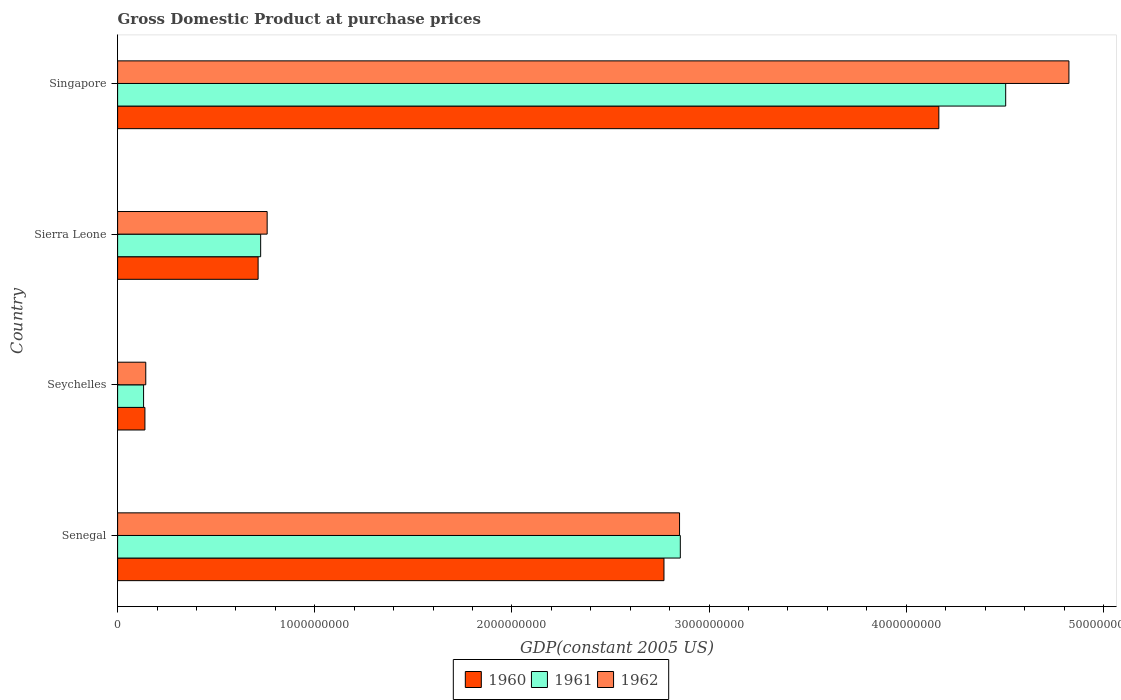How many different coloured bars are there?
Your answer should be very brief. 3. What is the label of the 4th group of bars from the top?
Ensure brevity in your answer.  Senegal. What is the GDP at purchase prices in 1961 in Sierra Leone?
Your answer should be very brief. 7.25e+08. Across all countries, what is the maximum GDP at purchase prices in 1962?
Your answer should be very brief. 4.82e+09. Across all countries, what is the minimum GDP at purchase prices in 1962?
Your answer should be very brief. 1.43e+08. In which country was the GDP at purchase prices in 1962 maximum?
Your answer should be compact. Singapore. In which country was the GDP at purchase prices in 1960 minimum?
Provide a short and direct response. Seychelles. What is the total GDP at purchase prices in 1962 in the graph?
Give a very brief answer. 8.58e+09. What is the difference between the GDP at purchase prices in 1960 in Sierra Leone and that in Singapore?
Your answer should be very brief. -3.45e+09. What is the difference between the GDP at purchase prices in 1961 in Sierra Leone and the GDP at purchase prices in 1962 in Senegal?
Ensure brevity in your answer.  -2.12e+09. What is the average GDP at purchase prices in 1961 per country?
Provide a succinct answer. 2.05e+09. What is the difference between the GDP at purchase prices in 1962 and GDP at purchase prices in 1961 in Seychelles?
Give a very brief answer. 1.11e+07. What is the ratio of the GDP at purchase prices in 1962 in Senegal to that in Seychelles?
Provide a succinct answer. 19.96. Is the GDP at purchase prices in 1960 in Senegal less than that in Singapore?
Your response must be concise. Yes. Is the difference between the GDP at purchase prices in 1962 in Senegal and Singapore greater than the difference between the GDP at purchase prices in 1961 in Senegal and Singapore?
Your answer should be very brief. No. What is the difference between the highest and the second highest GDP at purchase prices in 1962?
Make the answer very short. 1.97e+09. What is the difference between the highest and the lowest GDP at purchase prices in 1961?
Your answer should be very brief. 4.37e+09. In how many countries, is the GDP at purchase prices in 1961 greater than the average GDP at purchase prices in 1961 taken over all countries?
Ensure brevity in your answer.  2. What does the 3rd bar from the top in Seychelles represents?
Your answer should be compact. 1960. What does the 3rd bar from the bottom in Seychelles represents?
Your answer should be compact. 1962. Are all the bars in the graph horizontal?
Offer a terse response. Yes. How many countries are there in the graph?
Give a very brief answer. 4. What is the difference between two consecutive major ticks on the X-axis?
Your response must be concise. 1.00e+09. Does the graph contain any zero values?
Give a very brief answer. No. Does the graph contain grids?
Make the answer very short. No. Where does the legend appear in the graph?
Offer a very short reply. Bottom center. How many legend labels are there?
Ensure brevity in your answer.  3. How are the legend labels stacked?
Give a very brief answer. Horizontal. What is the title of the graph?
Ensure brevity in your answer.  Gross Domestic Product at purchase prices. Does "1991" appear as one of the legend labels in the graph?
Your answer should be very brief. No. What is the label or title of the X-axis?
Make the answer very short. GDP(constant 2005 US). What is the label or title of the Y-axis?
Keep it short and to the point. Country. What is the GDP(constant 2005 US) of 1960 in Senegal?
Make the answer very short. 2.77e+09. What is the GDP(constant 2005 US) in 1961 in Senegal?
Ensure brevity in your answer.  2.85e+09. What is the GDP(constant 2005 US) of 1962 in Senegal?
Your response must be concise. 2.85e+09. What is the GDP(constant 2005 US) of 1960 in Seychelles?
Your answer should be compact. 1.39e+08. What is the GDP(constant 2005 US) in 1961 in Seychelles?
Make the answer very short. 1.32e+08. What is the GDP(constant 2005 US) of 1962 in Seychelles?
Your answer should be compact. 1.43e+08. What is the GDP(constant 2005 US) of 1960 in Sierra Leone?
Ensure brevity in your answer.  7.13e+08. What is the GDP(constant 2005 US) in 1961 in Sierra Leone?
Make the answer very short. 7.25e+08. What is the GDP(constant 2005 US) in 1962 in Sierra Leone?
Give a very brief answer. 7.58e+08. What is the GDP(constant 2005 US) of 1960 in Singapore?
Your answer should be compact. 4.17e+09. What is the GDP(constant 2005 US) of 1961 in Singapore?
Keep it short and to the point. 4.50e+09. What is the GDP(constant 2005 US) in 1962 in Singapore?
Offer a terse response. 4.82e+09. Across all countries, what is the maximum GDP(constant 2005 US) in 1960?
Give a very brief answer. 4.17e+09. Across all countries, what is the maximum GDP(constant 2005 US) in 1961?
Provide a short and direct response. 4.50e+09. Across all countries, what is the maximum GDP(constant 2005 US) in 1962?
Provide a short and direct response. 4.82e+09. Across all countries, what is the minimum GDP(constant 2005 US) in 1960?
Ensure brevity in your answer.  1.39e+08. Across all countries, what is the minimum GDP(constant 2005 US) in 1961?
Your answer should be very brief. 1.32e+08. Across all countries, what is the minimum GDP(constant 2005 US) of 1962?
Give a very brief answer. 1.43e+08. What is the total GDP(constant 2005 US) of 1960 in the graph?
Keep it short and to the point. 7.79e+09. What is the total GDP(constant 2005 US) in 1961 in the graph?
Ensure brevity in your answer.  8.22e+09. What is the total GDP(constant 2005 US) of 1962 in the graph?
Your response must be concise. 8.58e+09. What is the difference between the GDP(constant 2005 US) of 1960 in Senegal and that in Seychelles?
Keep it short and to the point. 2.63e+09. What is the difference between the GDP(constant 2005 US) of 1961 in Senegal and that in Seychelles?
Give a very brief answer. 2.72e+09. What is the difference between the GDP(constant 2005 US) of 1962 in Senegal and that in Seychelles?
Provide a succinct answer. 2.71e+09. What is the difference between the GDP(constant 2005 US) of 1960 in Senegal and that in Sierra Leone?
Provide a short and direct response. 2.06e+09. What is the difference between the GDP(constant 2005 US) in 1961 in Senegal and that in Sierra Leone?
Keep it short and to the point. 2.13e+09. What is the difference between the GDP(constant 2005 US) of 1962 in Senegal and that in Sierra Leone?
Provide a short and direct response. 2.09e+09. What is the difference between the GDP(constant 2005 US) in 1960 in Senegal and that in Singapore?
Your answer should be very brief. -1.39e+09. What is the difference between the GDP(constant 2005 US) in 1961 in Senegal and that in Singapore?
Offer a very short reply. -1.65e+09. What is the difference between the GDP(constant 2005 US) in 1962 in Senegal and that in Singapore?
Your answer should be compact. -1.97e+09. What is the difference between the GDP(constant 2005 US) in 1960 in Seychelles and that in Sierra Leone?
Your answer should be very brief. -5.74e+08. What is the difference between the GDP(constant 2005 US) of 1961 in Seychelles and that in Sierra Leone?
Offer a very short reply. -5.94e+08. What is the difference between the GDP(constant 2005 US) in 1962 in Seychelles and that in Sierra Leone?
Provide a short and direct response. -6.16e+08. What is the difference between the GDP(constant 2005 US) in 1960 in Seychelles and that in Singapore?
Provide a short and direct response. -4.03e+09. What is the difference between the GDP(constant 2005 US) in 1961 in Seychelles and that in Singapore?
Make the answer very short. -4.37e+09. What is the difference between the GDP(constant 2005 US) of 1962 in Seychelles and that in Singapore?
Give a very brief answer. -4.68e+09. What is the difference between the GDP(constant 2005 US) of 1960 in Sierra Leone and that in Singapore?
Provide a succinct answer. -3.45e+09. What is the difference between the GDP(constant 2005 US) in 1961 in Sierra Leone and that in Singapore?
Offer a very short reply. -3.78e+09. What is the difference between the GDP(constant 2005 US) of 1962 in Sierra Leone and that in Singapore?
Your answer should be very brief. -4.07e+09. What is the difference between the GDP(constant 2005 US) of 1960 in Senegal and the GDP(constant 2005 US) of 1961 in Seychelles?
Offer a terse response. 2.64e+09. What is the difference between the GDP(constant 2005 US) in 1960 in Senegal and the GDP(constant 2005 US) in 1962 in Seychelles?
Your response must be concise. 2.63e+09. What is the difference between the GDP(constant 2005 US) in 1961 in Senegal and the GDP(constant 2005 US) in 1962 in Seychelles?
Give a very brief answer. 2.71e+09. What is the difference between the GDP(constant 2005 US) in 1960 in Senegal and the GDP(constant 2005 US) in 1961 in Sierra Leone?
Provide a succinct answer. 2.05e+09. What is the difference between the GDP(constant 2005 US) of 1960 in Senegal and the GDP(constant 2005 US) of 1962 in Sierra Leone?
Your answer should be very brief. 2.01e+09. What is the difference between the GDP(constant 2005 US) of 1961 in Senegal and the GDP(constant 2005 US) of 1962 in Sierra Leone?
Your response must be concise. 2.10e+09. What is the difference between the GDP(constant 2005 US) in 1960 in Senegal and the GDP(constant 2005 US) in 1961 in Singapore?
Make the answer very short. -1.73e+09. What is the difference between the GDP(constant 2005 US) of 1960 in Senegal and the GDP(constant 2005 US) of 1962 in Singapore?
Make the answer very short. -2.05e+09. What is the difference between the GDP(constant 2005 US) of 1961 in Senegal and the GDP(constant 2005 US) of 1962 in Singapore?
Offer a very short reply. -1.97e+09. What is the difference between the GDP(constant 2005 US) in 1960 in Seychelles and the GDP(constant 2005 US) in 1961 in Sierra Leone?
Your response must be concise. -5.87e+08. What is the difference between the GDP(constant 2005 US) in 1960 in Seychelles and the GDP(constant 2005 US) in 1962 in Sierra Leone?
Keep it short and to the point. -6.20e+08. What is the difference between the GDP(constant 2005 US) in 1961 in Seychelles and the GDP(constant 2005 US) in 1962 in Sierra Leone?
Make the answer very short. -6.27e+08. What is the difference between the GDP(constant 2005 US) of 1960 in Seychelles and the GDP(constant 2005 US) of 1961 in Singapore?
Your answer should be compact. -4.37e+09. What is the difference between the GDP(constant 2005 US) of 1960 in Seychelles and the GDP(constant 2005 US) of 1962 in Singapore?
Your response must be concise. -4.69e+09. What is the difference between the GDP(constant 2005 US) in 1961 in Seychelles and the GDP(constant 2005 US) in 1962 in Singapore?
Your response must be concise. -4.69e+09. What is the difference between the GDP(constant 2005 US) in 1960 in Sierra Leone and the GDP(constant 2005 US) in 1961 in Singapore?
Make the answer very short. -3.79e+09. What is the difference between the GDP(constant 2005 US) in 1960 in Sierra Leone and the GDP(constant 2005 US) in 1962 in Singapore?
Keep it short and to the point. -4.11e+09. What is the difference between the GDP(constant 2005 US) of 1961 in Sierra Leone and the GDP(constant 2005 US) of 1962 in Singapore?
Provide a short and direct response. -4.10e+09. What is the average GDP(constant 2005 US) in 1960 per country?
Ensure brevity in your answer.  1.95e+09. What is the average GDP(constant 2005 US) of 1961 per country?
Your answer should be compact. 2.05e+09. What is the average GDP(constant 2005 US) of 1962 per country?
Your response must be concise. 2.14e+09. What is the difference between the GDP(constant 2005 US) of 1960 and GDP(constant 2005 US) of 1961 in Senegal?
Offer a very short reply. -8.29e+07. What is the difference between the GDP(constant 2005 US) of 1960 and GDP(constant 2005 US) of 1962 in Senegal?
Offer a very short reply. -7.91e+07. What is the difference between the GDP(constant 2005 US) in 1961 and GDP(constant 2005 US) in 1962 in Senegal?
Offer a very short reply. 3.89e+06. What is the difference between the GDP(constant 2005 US) in 1960 and GDP(constant 2005 US) in 1961 in Seychelles?
Ensure brevity in your answer.  6.76e+06. What is the difference between the GDP(constant 2005 US) of 1960 and GDP(constant 2005 US) of 1962 in Seychelles?
Give a very brief answer. -4.32e+06. What is the difference between the GDP(constant 2005 US) of 1961 and GDP(constant 2005 US) of 1962 in Seychelles?
Your answer should be compact. -1.11e+07. What is the difference between the GDP(constant 2005 US) in 1960 and GDP(constant 2005 US) in 1961 in Sierra Leone?
Offer a very short reply. -1.29e+07. What is the difference between the GDP(constant 2005 US) in 1960 and GDP(constant 2005 US) in 1962 in Sierra Leone?
Keep it short and to the point. -4.58e+07. What is the difference between the GDP(constant 2005 US) of 1961 and GDP(constant 2005 US) of 1962 in Sierra Leone?
Your answer should be compact. -3.29e+07. What is the difference between the GDP(constant 2005 US) of 1960 and GDP(constant 2005 US) of 1961 in Singapore?
Your answer should be compact. -3.39e+08. What is the difference between the GDP(constant 2005 US) of 1960 and GDP(constant 2005 US) of 1962 in Singapore?
Make the answer very short. -6.60e+08. What is the difference between the GDP(constant 2005 US) of 1961 and GDP(constant 2005 US) of 1962 in Singapore?
Give a very brief answer. -3.21e+08. What is the ratio of the GDP(constant 2005 US) in 1960 in Senegal to that in Seychelles?
Keep it short and to the point. 20.01. What is the ratio of the GDP(constant 2005 US) of 1961 in Senegal to that in Seychelles?
Your response must be concise. 21.66. What is the ratio of the GDP(constant 2005 US) in 1962 in Senegal to that in Seychelles?
Provide a succinct answer. 19.96. What is the ratio of the GDP(constant 2005 US) of 1960 in Senegal to that in Sierra Leone?
Your response must be concise. 3.89. What is the ratio of the GDP(constant 2005 US) of 1961 in Senegal to that in Sierra Leone?
Keep it short and to the point. 3.93. What is the ratio of the GDP(constant 2005 US) of 1962 in Senegal to that in Sierra Leone?
Provide a short and direct response. 3.76. What is the ratio of the GDP(constant 2005 US) in 1960 in Senegal to that in Singapore?
Make the answer very short. 0.67. What is the ratio of the GDP(constant 2005 US) of 1961 in Senegal to that in Singapore?
Your answer should be compact. 0.63. What is the ratio of the GDP(constant 2005 US) in 1962 in Senegal to that in Singapore?
Offer a very short reply. 0.59. What is the ratio of the GDP(constant 2005 US) of 1960 in Seychelles to that in Sierra Leone?
Offer a very short reply. 0.19. What is the ratio of the GDP(constant 2005 US) in 1961 in Seychelles to that in Sierra Leone?
Provide a succinct answer. 0.18. What is the ratio of the GDP(constant 2005 US) of 1962 in Seychelles to that in Sierra Leone?
Ensure brevity in your answer.  0.19. What is the ratio of the GDP(constant 2005 US) of 1961 in Seychelles to that in Singapore?
Ensure brevity in your answer.  0.03. What is the ratio of the GDP(constant 2005 US) in 1962 in Seychelles to that in Singapore?
Your answer should be compact. 0.03. What is the ratio of the GDP(constant 2005 US) of 1960 in Sierra Leone to that in Singapore?
Your response must be concise. 0.17. What is the ratio of the GDP(constant 2005 US) in 1961 in Sierra Leone to that in Singapore?
Provide a succinct answer. 0.16. What is the ratio of the GDP(constant 2005 US) in 1962 in Sierra Leone to that in Singapore?
Ensure brevity in your answer.  0.16. What is the difference between the highest and the second highest GDP(constant 2005 US) in 1960?
Make the answer very short. 1.39e+09. What is the difference between the highest and the second highest GDP(constant 2005 US) of 1961?
Give a very brief answer. 1.65e+09. What is the difference between the highest and the second highest GDP(constant 2005 US) of 1962?
Make the answer very short. 1.97e+09. What is the difference between the highest and the lowest GDP(constant 2005 US) of 1960?
Ensure brevity in your answer.  4.03e+09. What is the difference between the highest and the lowest GDP(constant 2005 US) of 1961?
Your answer should be compact. 4.37e+09. What is the difference between the highest and the lowest GDP(constant 2005 US) of 1962?
Provide a succinct answer. 4.68e+09. 